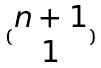<formula> <loc_0><loc_0><loc_500><loc_500>( \begin{matrix} n + 1 \\ 1 \end{matrix} )</formula> 